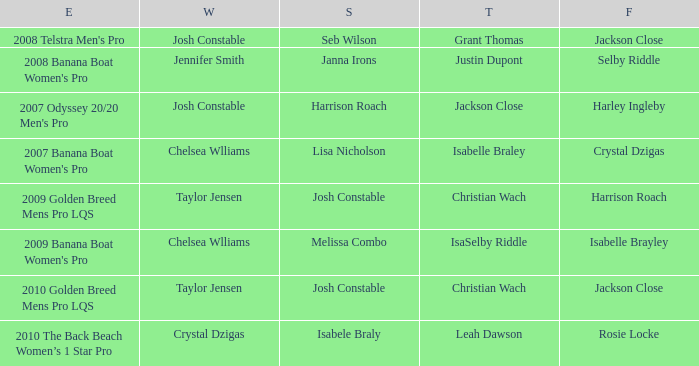Who secured the fourth position in the 2008 telstra men's pro event? Jackson Close. 